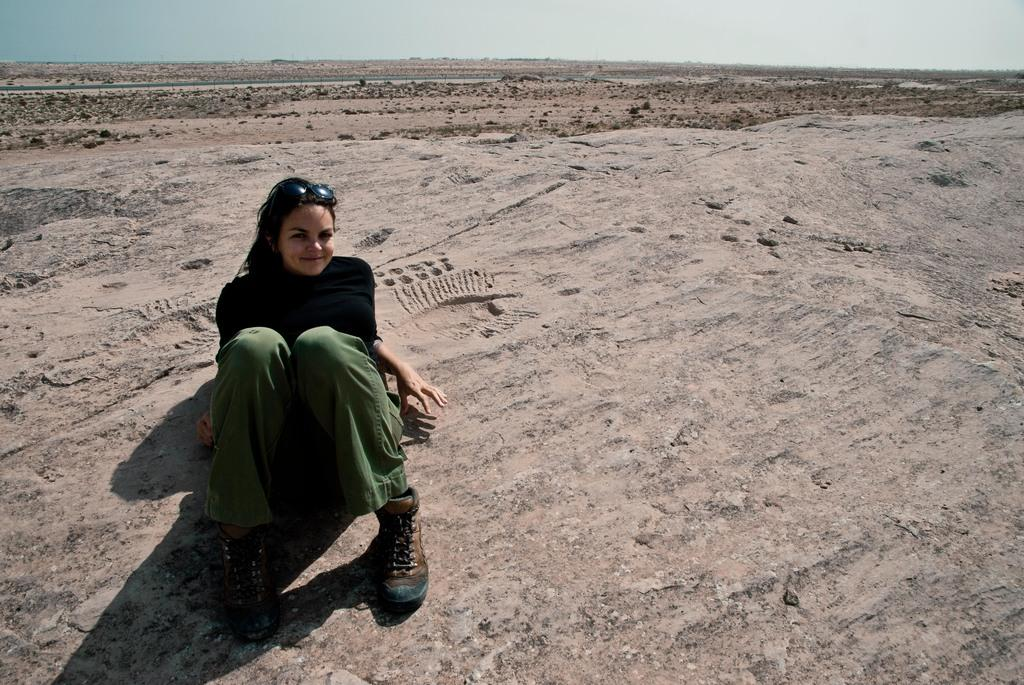Who is the main subject in the image? There is a lady in the image. What is the lady doing in the image? The lady is sitting on the land. What color is the lady's top? She is wearing a black top. What color are the lady's pants? She is wearing grey pants. What type of footwear is the lady wearing? She is wearing boots. How does the ant contribute to the heat in the image? There are no ants present in the image, so it is not possible to determine their contribution to the heat. 